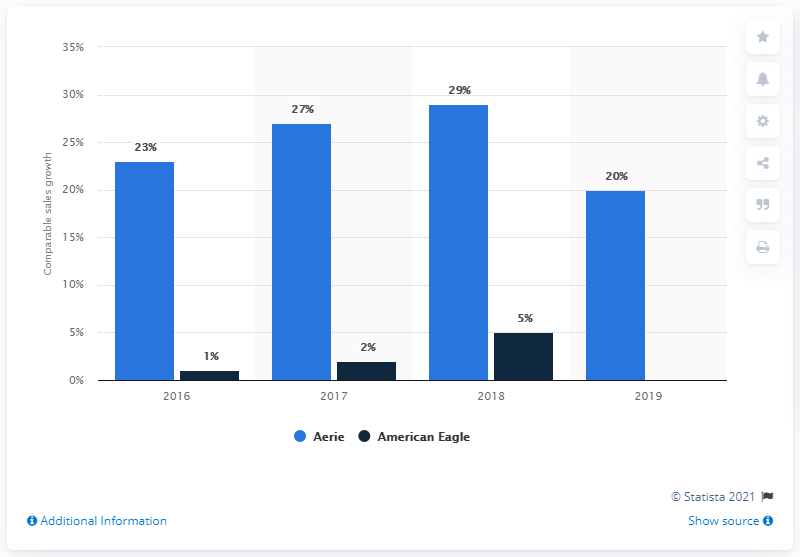Which year showed the highest growth for Aerie according to this graph? According to the graph, Aerie experienced the highest growth in 2018, with a comparative sales growth of 29%. 